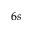<formula> <loc_0><loc_0><loc_500><loc_500>6 s</formula> 